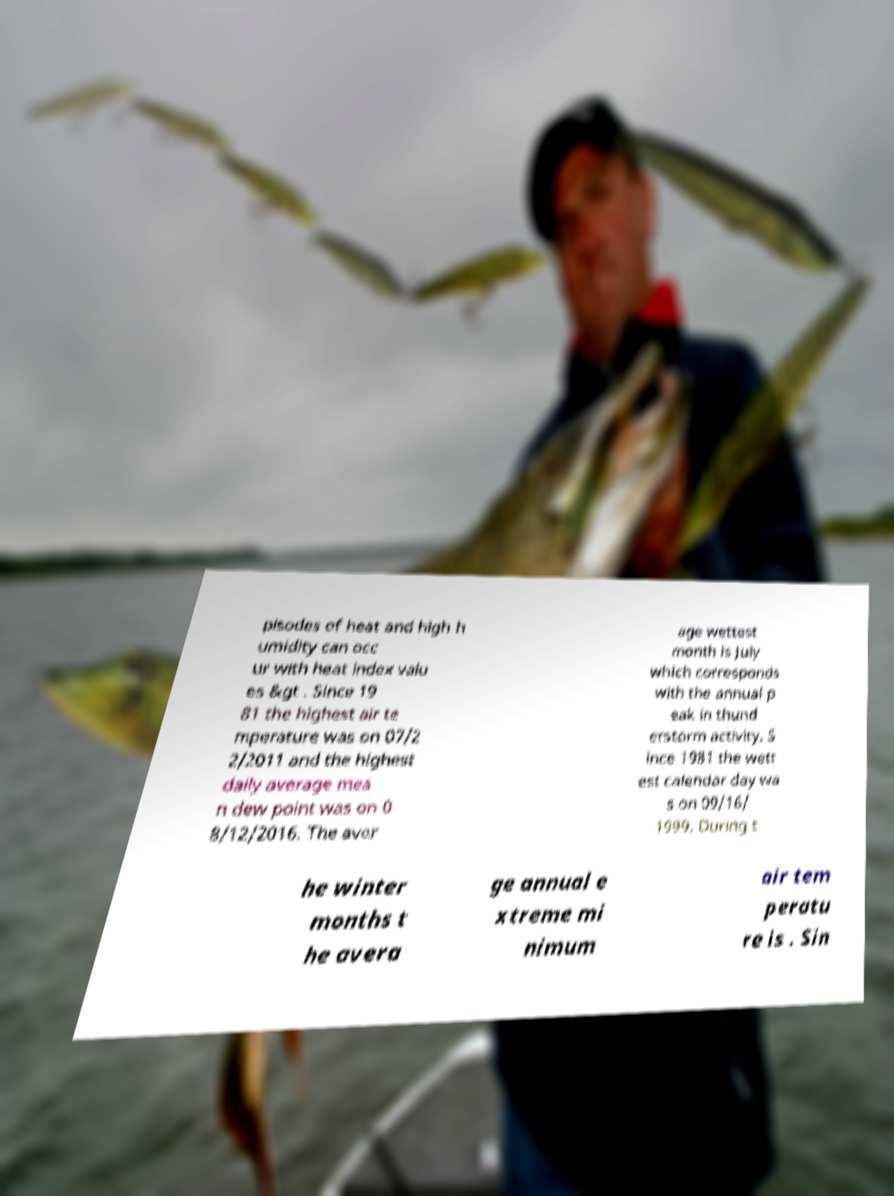Can you accurately transcribe the text from the provided image for me? pisodes of heat and high h umidity can occ ur with heat index valu es &gt . Since 19 81 the highest air te mperature was on 07/2 2/2011 and the highest daily average mea n dew point was on 0 8/12/2016. The aver age wettest month is July which corresponds with the annual p eak in thund erstorm activity. S ince 1981 the wett est calendar day wa s on 09/16/ 1999. During t he winter months t he avera ge annual e xtreme mi nimum air tem peratu re is . Sin 